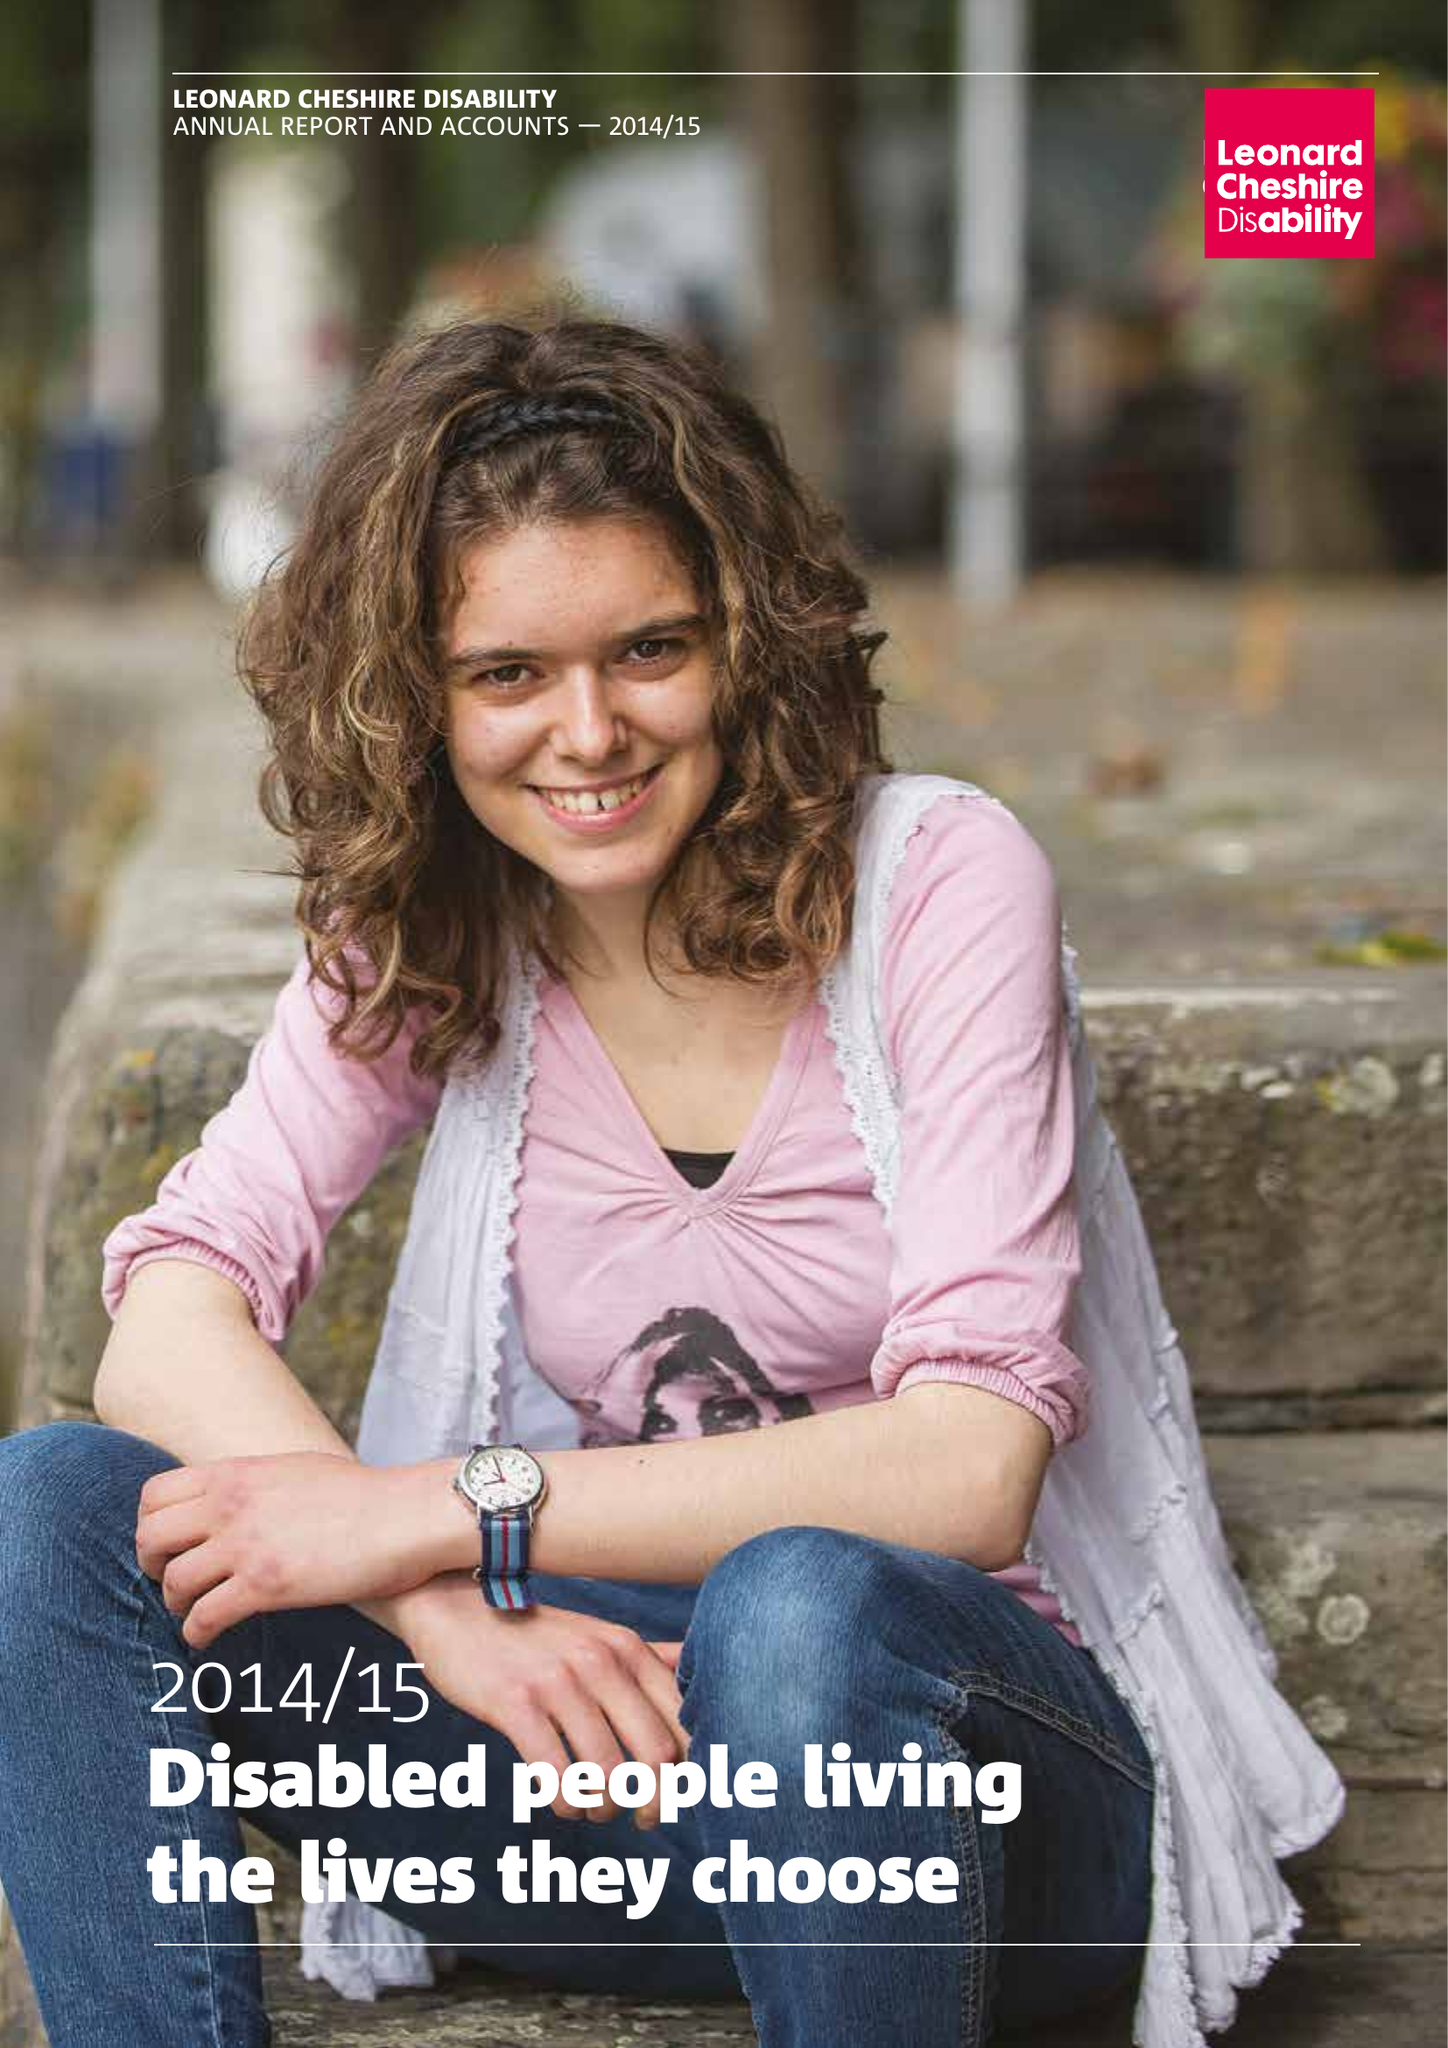What is the value for the address__post_town?
Answer the question using a single word or phrase. LONDON 